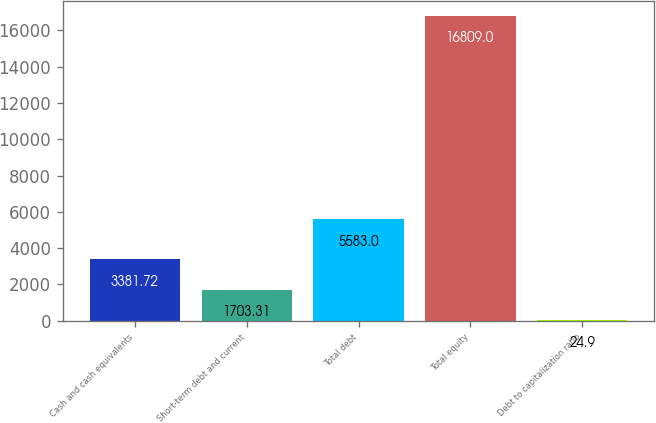<chart> <loc_0><loc_0><loc_500><loc_500><bar_chart><fcel>Cash and cash equivalents<fcel>Short-term debt and current<fcel>Total debt<fcel>Total equity<fcel>Debt to capitalization ratio<nl><fcel>3381.72<fcel>1703.31<fcel>5583<fcel>16809<fcel>24.9<nl></chart> 